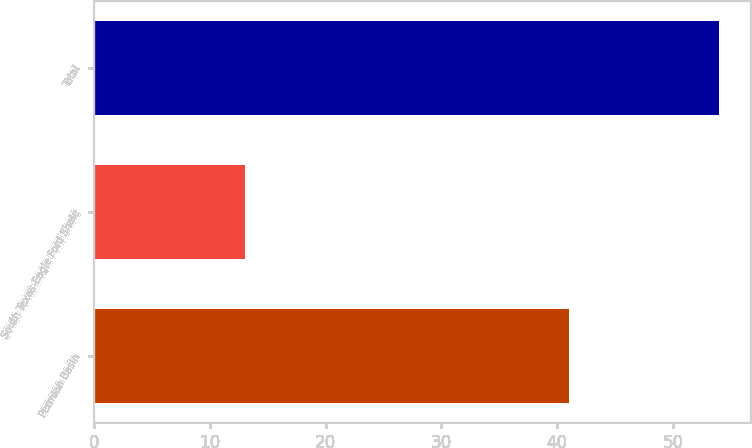Convert chart to OTSL. <chart><loc_0><loc_0><loc_500><loc_500><bar_chart><fcel>Permian Basin<fcel>South Texas-Eagle Ford Shale<fcel>Total<nl><fcel>41<fcel>13<fcel>54<nl></chart> 